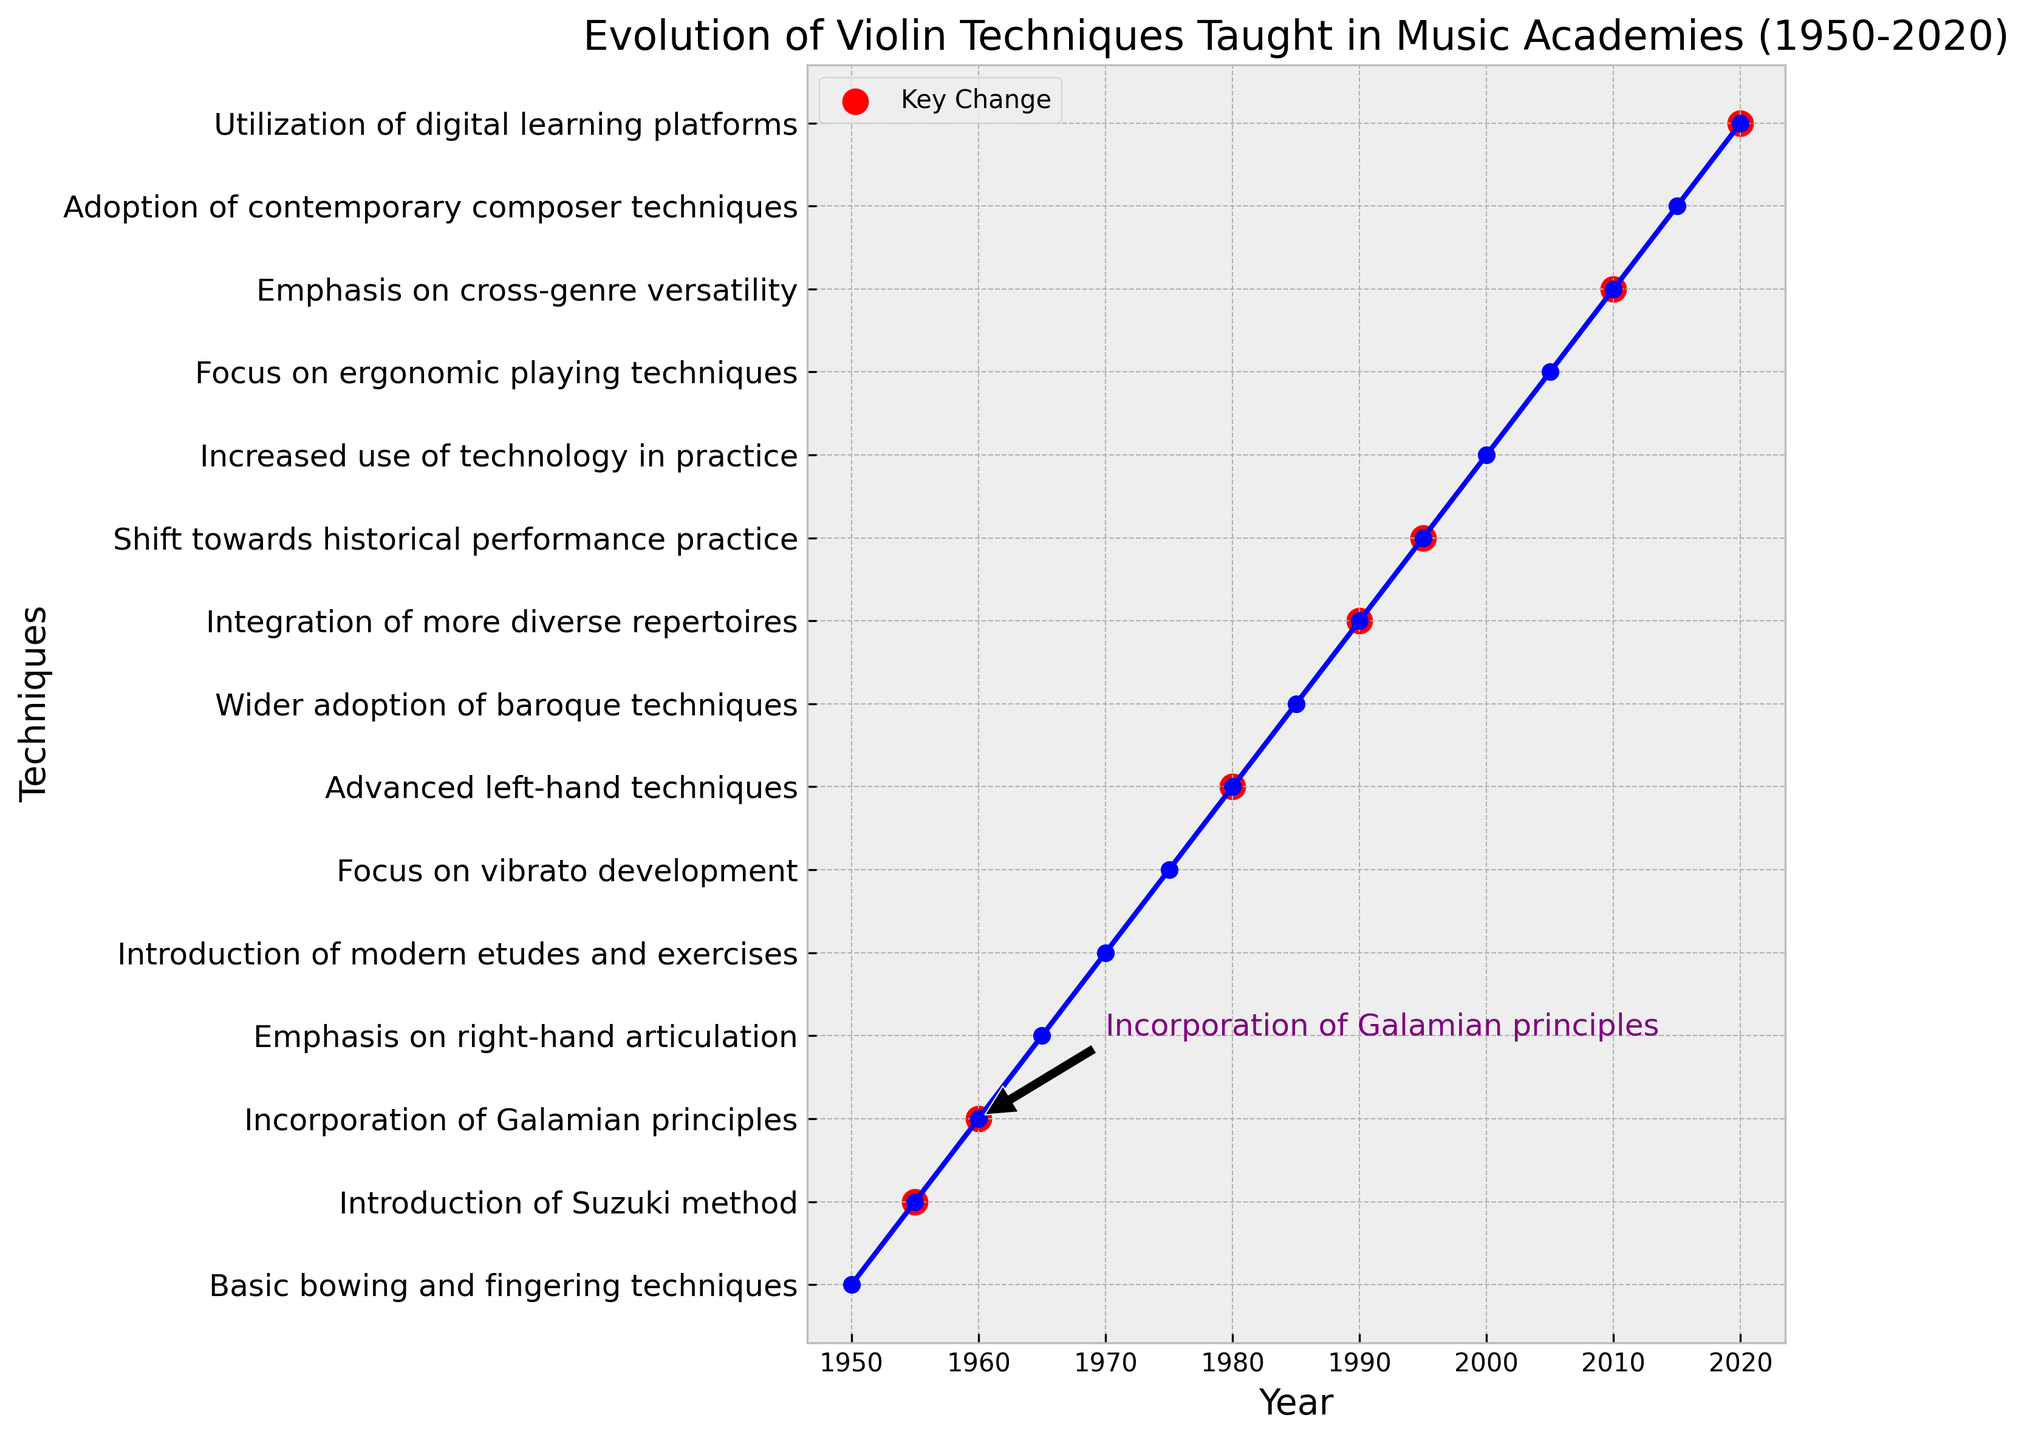Which technique was introduced around 1960? Look for the annotation. The annotation points out that "Incorporation of Galamian principles" was introduced in 1960.
Answer: Incorporation of Galamian principles How many key changes are marked between 1950 and 2020? Count the red markers indicating key changes. There are markers placed in 1955, 1960, 1980, 1990, 1995, 2010, and 2020.
Answer: 7 What trend is noticeable about the evolution of violin techniques in the 1990s and 2000s? Observe the techniques listed along the y-axis for these decades. The 1990s show techniques like "Integration of more diverse repertoires" and "Shift towards historical performance practice." The 2000s emphasize "Increased use of technology in practice" and "Focus on ergonomic playing techniques." Both decades show a trend towards integrating diverse approaches and new technologies.
Answer: Trend towards diversity and technology What is the relationship between the "Shift towards historical performance practice" and key changes? Compare the occurrence of the shift and the presence of key changes. "Shift towards historical performance practice" occurs in 1995, and there is a red marker indicating it is a key change.
Answer: Key change Which year marked a focus on vibrato development without being considered a key change? Identify the year and check the color associated with vibrato development. It's the year 1975, with no red marker, indicating it's not considered a key change.
Answer: 1975 How does the focus on right-hand techniques evolve over time? Look for years emphasizing right-hand techniques. In 1965, there is an "Emphasis on right-hand articulation." This technique appears without any significant subsequent developments in the following years, indicating a single-focused approach.
Answer: Single-focused evolution in 1965 Which years represent the first and last key changes shown? Identify the years of the first and last red markers. The first key change is in 1955 (Introduction of Suzuki method), and the last one is in 2020 (Utilization of digital learning platforms).
Answer: 1955 and 2020 Which technique, emphasized in the 1980s, indicates a key change, and what is its focus? Identify the technique in the 1980s and look for the red marker. "Advanced left-hand techniques" in 1980 shows a key change.
Answer: Advanced left-hand techniques What color represents key changes in the plot? Look for the color used to highlight key changes in the plot. The red markers indicate key changes.
Answer: Red 